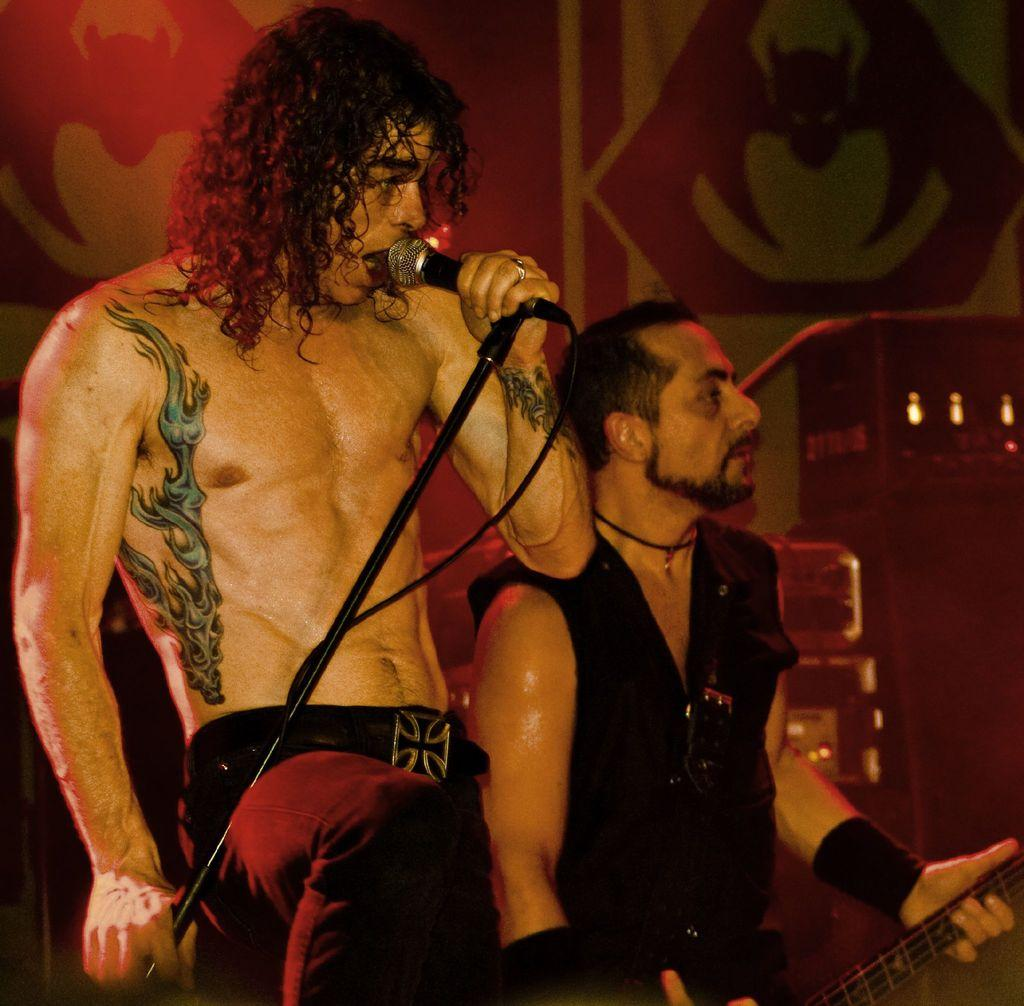What is the appearance of the man in the image? The man in the image has short hair. What is the man holding in the image? The man is holding a microphone. Can you describe the other person in the image? There is a person holding a guitar in the image. What type of eggnog is being served at the concert in the image? There is no mention of eggnog or a concert in the image; it features a man with short hair holding a microphone and a person holding a guitar. 